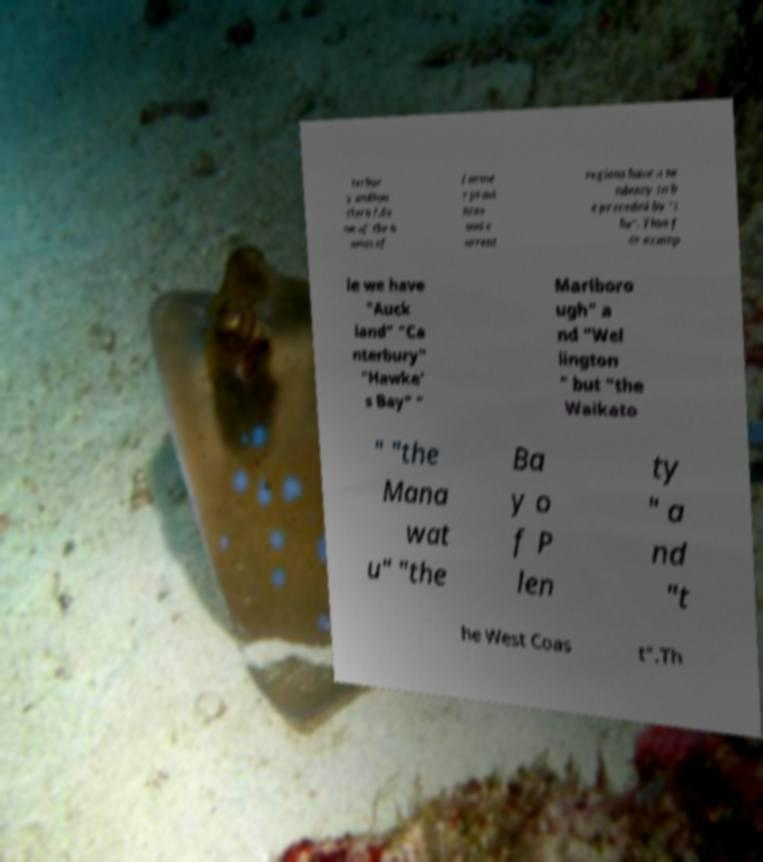Can you accurately transcribe the text from the provided image for me? terbur y andSou thern †.So me of the n ames of forme r provi nces and c urrent regions have a te ndency to b e preceded by "t he". Thus f or examp le we have "Auck land" "Ca nterbury" "Hawke' s Bay" " Marlboro ugh" a nd "Wel lington " but "the Waikato " "the Mana wat u" "the Ba y o f P len ty " a nd "t he West Coas t".Th 